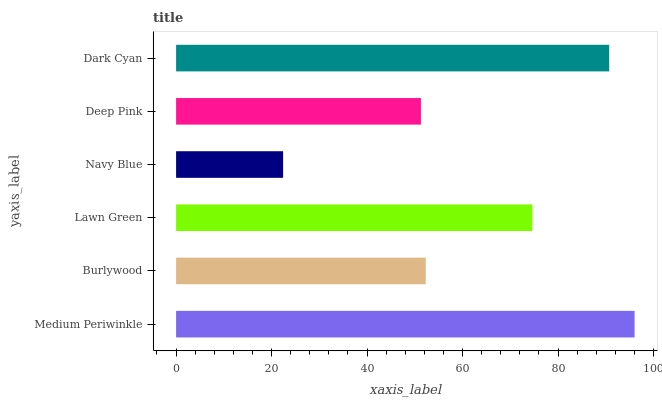Is Navy Blue the minimum?
Answer yes or no. Yes. Is Medium Periwinkle the maximum?
Answer yes or no. Yes. Is Burlywood the minimum?
Answer yes or no. No. Is Burlywood the maximum?
Answer yes or no. No. Is Medium Periwinkle greater than Burlywood?
Answer yes or no. Yes. Is Burlywood less than Medium Periwinkle?
Answer yes or no. Yes. Is Burlywood greater than Medium Periwinkle?
Answer yes or no. No. Is Medium Periwinkle less than Burlywood?
Answer yes or no. No. Is Lawn Green the high median?
Answer yes or no. Yes. Is Burlywood the low median?
Answer yes or no. Yes. Is Burlywood the high median?
Answer yes or no. No. Is Medium Periwinkle the low median?
Answer yes or no. No. 